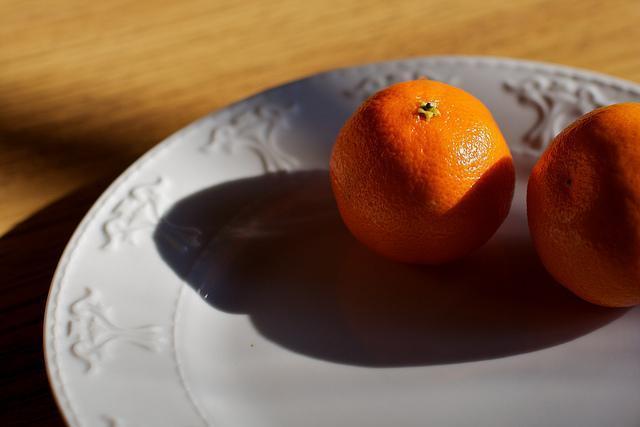How many oranges are there?
Give a very brief answer. 2. How many horses are there?
Give a very brief answer. 0. 